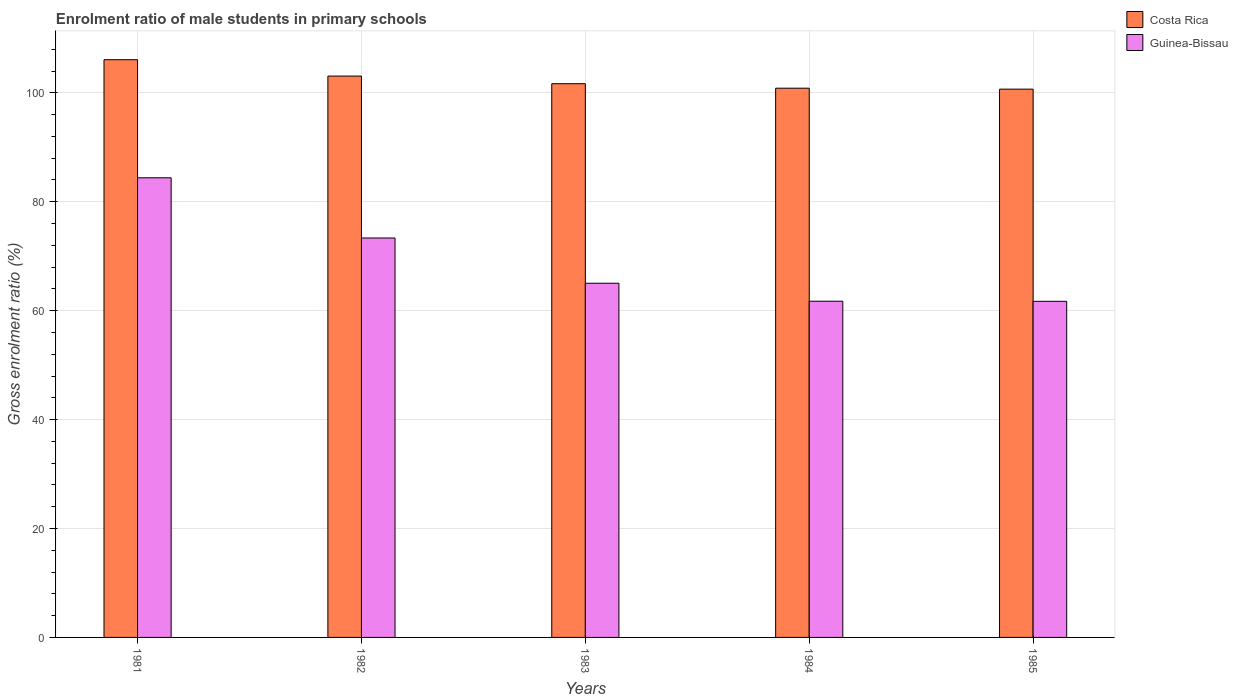Are the number of bars per tick equal to the number of legend labels?
Your response must be concise. Yes. How many bars are there on the 4th tick from the right?
Your answer should be very brief. 2. In how many cases, is the number of bars for a given year not equal to the number of legend labels?
Ensure brevity in your answer.  0. What is the enrolment ratio of male students in primary schools in Costa Rica in 1985?
Keep it short and to the point. 100.68. Across all years, what is the maximum enrolment ratio of male students in primary schools in Guinea-Bissau?
Your answer should be very brief. 84.4. Across all years, what is the minimum enrolment ratio of male students in primary schools in Guinea-Bissau?
Your answer should be compact. 61.72. In which year was the enrolment ratio of male students in primary schools in Costa Rica maximum?
Keep it short and to the point. 1981. In which year was the enrolment ratio of male students in primary schools in Costa Rica minimum?
Your answer should be compact. 1985. What is the total enrolment ratio of male students in primary schools in Costa Rica in the graph?
Keep it short and to the point. 512.37. What is the difference between the enrolment ratio of male students in primary schools in Costa Rica in 1981 and that in 1984?
Make the answer very short. 5.23. What is the difference between the enrolment ratio of male students in primary schools in Guinea-Bissau in 1981 and the enrolment ratio of male students in primary schools in Costa Rica in 1983?
Your response must be concise. -17.28. What is the average enrolment ratio of male students in primary schools in Costa Rica per year?
Your answer should be compact. 102.47. In the year 1984, what is the difference between the enrolment ratio of male students in primary schools in Costa Rica and enrolment ratio of male students in primary schools in Guinea-Bissau?
Give a very brief answer. 39.12. What is the ratio of the enrolment ratio of male students in primary schools in Guinea-Bissau in 1984 to that in 1985?
Provide a short and direct response. 1. Is the enrolment ratio of male students in primary schools in Costa Rica in 1981 less than that in 1984?
Your response must be concise. No. What is the difference between the highest and the second highest enrolment ratio of male students in primary schools in Costa Rica?
Your response must be concise. 3. What is the difference between the highest and the lowest enrolment ratio of male students in primary schools in Guinea-Bissau?
Your answer should be very brief. 22.68. In how many years, is the enrolment ratio of male students in primary schools in Guinea-Bissau greater than the average enrolment ratio of male students in primary schools in Guinea-Bissau taken over all years?
Your answer should be very brief. 2. What does the 1st bar from the left in 1985 represents?
Your answer should be very brief. Costa Rica. What does the 2nd bar from the right in 1981 represents?
Give a very brief answer. Costa Rica. How many years are there in the graph?
Offer a terse response. 5. Are the values on the major ticks of Y-axis written in scientific E-notation?
Ensure brevity in your answer.  No. How many legend labels are there?
Provide a short and direct response. 2. How are the legend labels stacked?
Your response must be concise. Vertical. What is the title of the graph?
Your response must be concise. Enrolment ratio of male students in primary schools. Does "Uruguay" appear as one of the legend labels in the graph?
Keep it short and to the point. No. What is the Gross enrolment ratio (%) in Costa Rica in 1981?
Your answer should be very brief. 106.08. What is the Gross enrolment ratio (%) of Guinea-Bissau in 1981?
Keep it short and to the point. 84.4. What is the Gross enrolment ratio (%) of Costa Rica in 1982?
Your answer should be very brief. 103.08. What is the Gross enrolment ratio (%) of Guinea-Bissau in 1982?
Offer a terse response. 73.35. What is the Gross enrolment ratio (%) of Costa Rica in 1983?
Give a very brief answer. 101.68. What is the Gross enrolment ratio (%) of Guinea-Bissau in 1983?
Make the answer very short. 65.04. What is the Gross enrolment ratio (%) of Costa Rica in 1984?
Your answer should be compact. 100.85. What is the Gross enrolment ratio (%) in Guinea-Bissau in 1984?
Your answer should be very brief. 61.74. What is the Gross enrolment ratio (%) of Costa Rica in 1985?
Offer a terse response. 100.68. What is the Gross enrolment ratio (%) in Guinea-Bissau in 1985?
Keep it short and to the point. 61.72. Across all years, what is the maximum Gross enrolment ratio (%) of Costa Rica?
Offer a terse response. 106.08. Across all years, what is the maximum Gross enrolment ratio (%) of Guinea-Bissau?
Offer a terse response. 84.4. Across all years, what is the minimum Gross enrolment ratio (%) in Costa Rica?
Your response must be concise. 100.68. Across all years, what is the minimum Gross enrolment ratio (%) in Guinea-Bissau?
Provide a succinct answer. 61.72. What is the total Gross enrolment ratio (%) of Costa Rica in the graph?
Offer a terse response. 512.37. What is the total Gross enrolment ratio (%) in Guinea-Bissau in the graph?
Offer a terse response. 346.24. What is the difference between the Gross enrolment ratio (%) in Costa Rica in 1981 and that in 1982?
Your answer should be compact. 3. What is the difference between the Gross enrolment ratio (%) of Guinea-Bissau in 1981 and that in 1982?
Offer a terse response. 11.05. What is the difference between the Gross enrolment ratio (%) of Costa Rica in 1981 and that in 1983?
Keep it short and to the point. 4.41. What is the difference between the Gross enrolment ratio (%) in Guinea-Bissau in 1981 and that in 1983?
Your response must be concise. 19.36. What is the difference between the Gross enrolment ratio (%) of Costa Rica in 1981 and that in 1984?
Ensure brevity in your answer.  5.23. What is the difference between the Gross enrolment ratio (%) in Guinea-Bissau in 1981 and that in 1984?
Your response must be concise. 22.66. What is the difference between the Gross enrolment ratio (%) in Costa Rica in 1981 and that in 1985?
Keep it short and to the point. 5.41. What is the difference between the Gross enrolment ratio (%) in Guinea-Bissau in 1981 and that in 1985?
Provide a short and direct response. 22.68. What is the difference between the Gross enrolment ratio (%) of Costa Rica in 1982 and that in 1983?
Keep it short and to the point. 1.4. What is the difference between the Gross enrolment ratio (%) in Guinea-Bissau in 1982 and that in 1983?
Ensure brevity in your answer.  8.31. What is the difference between the Gross enrolment ratio (%) in Costa Rica in 1982 and that in 1984?
Give a very brief answer. 2.23. What is the difference between the Gross enrolment ratio (%) of Guinea-Bissau in 1982 and that in 1984?
Provide a short and direct response. 11.61. What is the difference between the Gross enrolment ratio (%) in Costa Rica in 1982 and that in 1985?
Provide a succinct answer. 2.4. What is the difference between the Gross enrolment ratio (%) in Guinea-Bissau in 1982 and that in 1985?
Give a very brief answer. 11.63. What is the difference between the Gross enrolment ratio (%) in Costa Rica in 1983 and that in 1984?
Your response must be concise. 0.82. What is the difference between the Gross enrolment ratio (%) of Guinea-Bissau in 1983 and that in 1984?
Your response must be concise. 3.3. What is the difference between the Gross enrolment ratio (%) of Costa Rica in 1983 and that in 1985?
Make the answer very short. 1. What is the difference between the Gross enrolment ratio (%) of Guinea-Bissau in 1983 and that in 1985?
Give a very brief answer. 3.32. What is the difference between the Gross enrolment ratio (%) in Costa Rica in 1984 and that in 1985?
Your response must be concise. 0.17. What is the difference between the Gross enrolment ratio (%) in Guinea-Bissau in 1984 and that in 1985?
Give a very brief answer. 0.02. What is the difference between the Gross enrolment ratio (%) of Costa Rica in 1981 and the Gross enrolment ratio (%) of Guinea-Bissau in 1982?
Provide a succinct answer. 32.74. What is the difference between the Gross enrolment ratio (%) of Costa Rica in 1981 and the Gross enrolment ratio (%) of Guinea-Bissau in 1983?
Offer a terse response. 41.05. What is the difference between the Gross enrolment ratio (%) of Costa Rica in 1981 and the Gross enrolment ratio (%) of Guinea-Bissau in 1984?
Offer a very short reply. 44.35. What is the difference between the Gross enrolment ratio (%) in Costa Rica in 1981 and the Gross enrolment ratio (%) in Guinea-Bissau in 1985?
Provide a succinct answer. 44.37. What is the difference between the Gross enrolment ratio (%) of Costa Rica in 1982 and the Gross enrolment ratio (%) of Guinea-Bissau in 1983?
Provide a succinct answer. 38.04. What is the difference between the Gross enrolment ratio (%) of Costa Rica in 1982 and the Gross enrolment ratio (%) of Guinea-Bissau in 1984?
Ensure brevity in your answer.  41.34. What is the difference between the Gross enrolment ratio (%) of Costa Rica in 1982 and the Gross enrolment ratio (%) of Guinea-Bissau in 1985?
Provide a short and direct response. 41.36. What is the difference between the Gross enrolment ratio (%) of Costa Rica in 1983 and the Gross enrolment ratio (%) of Guinea-Bissau in 1984?
Give a very brief answer. 39.94. What is the difference between the Gross enrolment ratio (%) of Costa Rica in 1983 and the Gross enrolment ratio (%) of Guinea-Bissau in 1985?
Offer a very short reply. 39.96. What is the difference between the Gross enrolment ratio (%) of Costa Rica in 1984 and the Gross enrolment ratio (%) of Guinea-Bissau in 1985?
Offer a terse response. 39.14. What is the average Gross enrolment ratio (%) in Costa Rica per year?
Your answer should be very brief. 102.47. What is the average Gross enrolment ratio (%) in Guinea-Bissau per year?
Make the answer very short. 69.25. In the year 1981, what is the difference between the Gross enrolment ratio (%) of Costa Rica and Gross enrolment ratio (%) of Guinea-Bissau?
Your answer should be compact. 21.68. In the year 1982, what is the difference between the Gross enrolment ratio (%) of Costa Rica and Gross enrolment ratio (%) of Guinea-Bissau?
Your answer should be compact. 29.73. In the year 1983, what is the difference between the Gross enrolment ratio (%) in Costa Rica and Gross enrolment ratio (%) in Guinea-Bissau?
Keep it short and to the point. 36.64. In the year 1984, what is the difference between the Gross enrolment ratio (%) of Costa Rica and Gross enrolment ratio (%) of Guinea-Bissau?
Your answer should be compact. 39.12. In the year 1985, what is the difference between the Gross enrolment ratio (%) of Costa Rica and Gross enrolment ratio (%) of Guinea-Bissau?
Offer a terse response. 38.96. What is the ratio of the Gross enrolment ratio (%) of Costa Rica in 1981 to that in 1982?
Give a very brief answer. 1.03. What is the ratio of the Gross enrolment ratio (%) in Guinea-Bissau in 1981 to that in 1982?
Your answer should be very brief. 1.15. What is the ratio of the Gross enrolment ratio (%) of Costa Rica in 1981 to that in 1983?
Keep it short and to the point. 1.04. What is the ratio of the Gross enrolment ratio (%) in Guinea-Bissau in 1981 to that in 1983?
Your answer should be very brief. 1.3. What is the ratio of the Gross enrolment ratio (%) of Costa Rica in 1981 to that in 1984?
Your response must be concise. 1.05. What is the ratio of the Gross enrolment ratio (%) of Guinea-Bissau in 1981 to that in 1984?
Offer a very short reply. 1.37. What is the ratio of the Gross enrolment ratio (%) of Costa Rica in 1981 to that in 1985?
Make the answer very short. 1.05. What is the ratio of the Gross enrolment ratio (%) of Guinea-Bissau in 1981 to that in 1985?
Your response must be concise. 1.37. What is the ratio of the Gross enrolment ratio (%) in Costa Rica in 1982 to that in 1983?
Offer a terse response. 1.01. What is the ratio of the Gross enrolment ratio (%) in Guinea-Bissau in 1982 to that in 1983?
Provide a short and direct response. 1.13. What is the ratio of the Gross enrolment ratio (%) in Costa Rica in 1982 to that in 1984?
Your response must be concise. 1.02. What is the ratio of the Gross enrolment ratio (%) of Guinea-Bissau in 1982 to that in 1984?
Your answer should be compact. 1.19. What is the ratio of the Gross enrolment ratio (%) in Costa Rica in 1982 to that in 1985?
Your answer should be very brief. 1.02. What is the ratio of the Gross enrolment ratio (%) in Guinea-Bissau in 1982 to that in 1985?
Offer a very short reply. 1.19. What is the ratio of the Gross enrolment ratio (%) of Costa Rica in 1983 to that in 1984?
Your response must be concise. 1.01. What is the ratio of the Gross enrolment ratio (%) in Guinea-Bissau in 1983 to that in 1984?
Offer a terse response. 1.05. What is the ratio of the Gross enrolment ratio (%) of Costa Rica in 1983 to that in 1985?
Your answer should be compact. 1.01. What is the ratio of the Gross enrolment ratio (%) in Guinea-Bissau in 1983 to that in 1985?
Make the answer very short. 1.05. What is the ratio of the Gross enrolment ratio (%) of Guinea-Bissau in 1984 to that in 1985?
Keep it short and to the point. 1. What is the difference between the highest and the second highest Gross enrolment ratio (%) in Costa Rica?
Keep it short and to the point. 3. What is the difference between the highest and the second highest Gross enrolment ratio (%) in Guinea-Bissau?
Your response must be concise. 11.05. What is the difference between the highest and the lowest Gross enrolment ratio (%) of Costa Rica?
Provide a succinct answer. 5.41. What is the difference between the highest and the lowest Gross enrolment ratio (%) of Guinea-Bissau?
Offer a terse response. 22.68. 